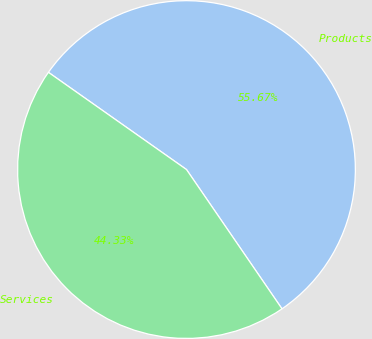Convert chart. <chart><loc_0><loc_0><loc_500><loc_500><pie_chart><fcel>Products<fcel>Services<nl><fcel>55.67%<fcel>44.33%<nl></chart> 